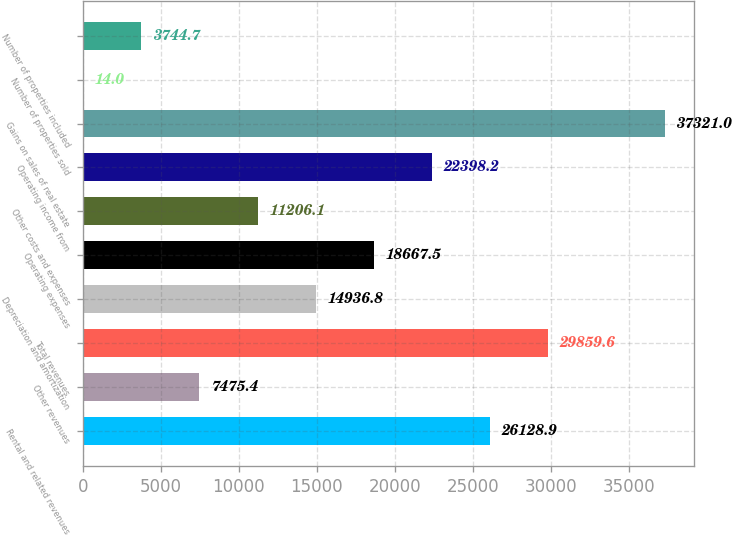<chart> <loc_0><loc_0><loc_500><loc_500><bar_chart><fcel>Rental and related revenues<fcel>Other revenues<fcel>Total revenues<fcel>Depreciation and amortization<fcel>Operating expenses<fcel>Other costs and expenses<fcel>Operating income from<fcel>Gains on sales of real estate<fcel>Number of properties sold<fcel>Number of properties included<nl><fcel>26128.9<fcel>7475.4<fcel>29859.6<fcel>14936.8<fcel>18667.5<fcel>11206.1<fcel>22398.2<fcel>37321<fcel>14<fcel>3744.7<nl></chart> 